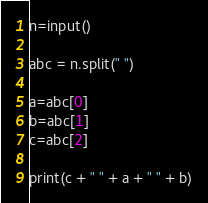<code> <loc_0><loc_0><loc_500><loc_500><_Python_>n=input()

abc = n.split(" ")

a=abc[0]
b=abc[1]
c=abc[2]

print(c + " " + a + " " + b)</code> 